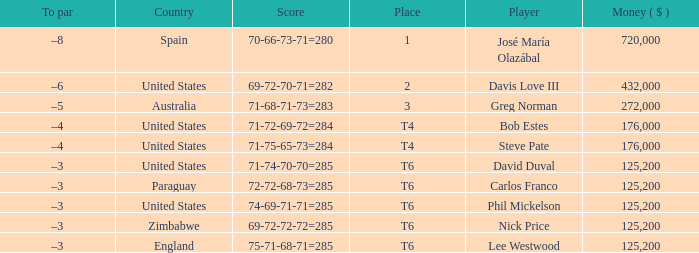Which average money has a Score of 69-72-72-72=285? 125200.0. Write the full table. {'header': ['To par', 'Country', 'Score', 'Place', 'Player', 'Money ( $ )'], 'rows': [['–8', 'Spain', '70-66-73-71=280', '1', 'José María Olazábal', '720,000'], ['–6', 'United States', '69-72-70-71=282', '2', 'Davis Love III', '432,000'], ['–5', 'Australia', '71-68-71-73=283', '3', 'Greg Norman', '272,000'], ['–4', 'United States', '71-72-69-72=284', 'T4', 'Bob Estes', '176,000'], ['–4', 'United States', '71-75-65-73=284', 'T4', 'Steve Pate', '176,000'], ['–3', 'United States', '71-74-70-70=285', 'T6', 'David Duval', '125,200'], ['–3', 'Paraguay', '72-72-68-73=285', 'T6', 'Carlos Franco', '125,200'], ['–3', 'United States', '74-69-71-71=285', 'T6', 'Phil Mickelson', '125,200'], ['–3', 'Zimbabwe', '69-72-72-72=285', 'T6', 'Nick Price', '125,200'], ['–3', 'England', '75-71-68-71=285', 'T6', 'Lee Westwood', '125,200']]} 